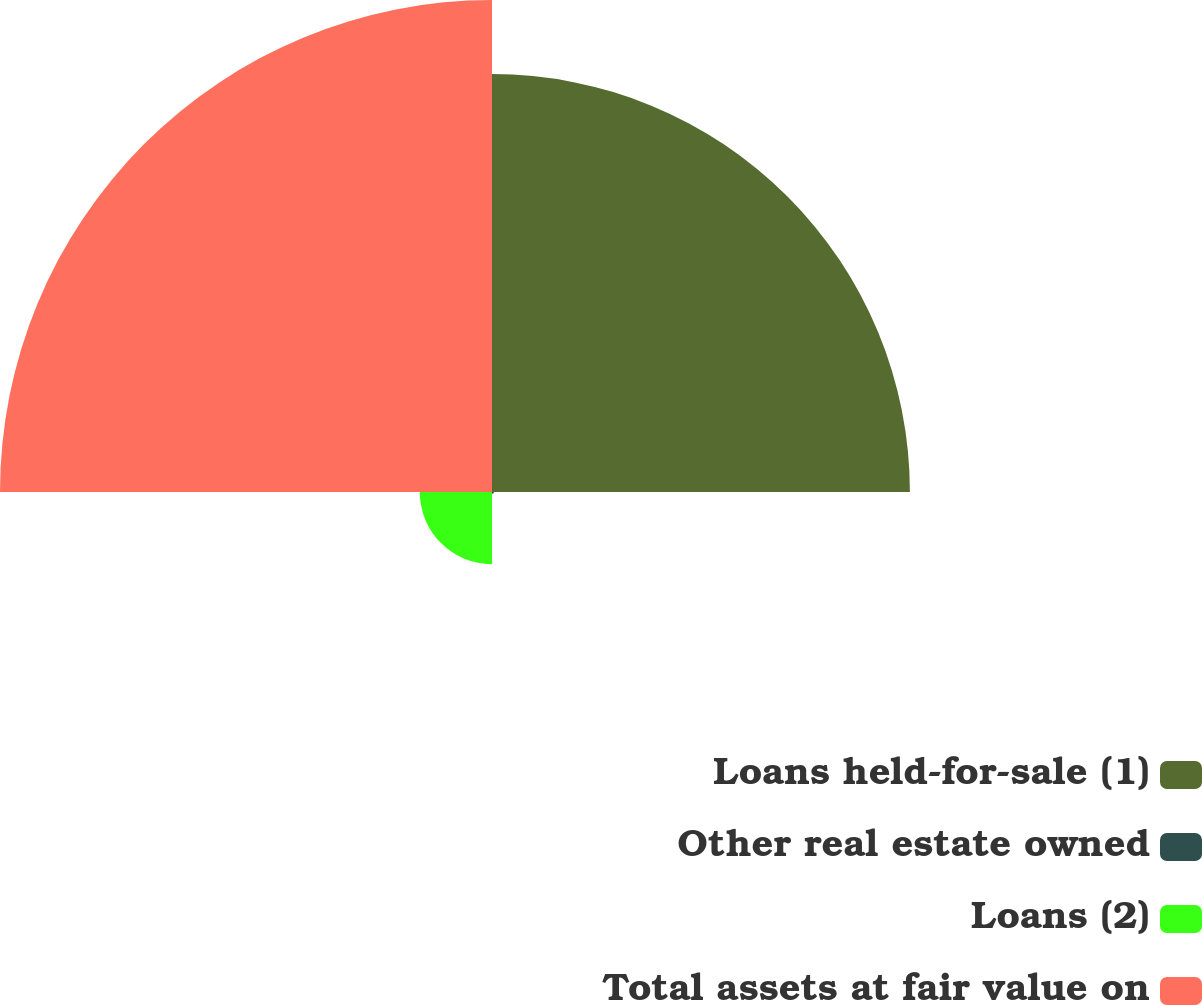Convert chart. <chart><loc_0><loc_0><loc_500><loc_500><pie_chart><fcel>Loans held-for-sale (1)<fcel>Other real estate owned<fcel>Loans (2)<fcel>Total assets at fair value on<nl><fcel>42.47%<fcel>0.19%<fcel>7.34%<fcel>50.0%<nl></chart> 